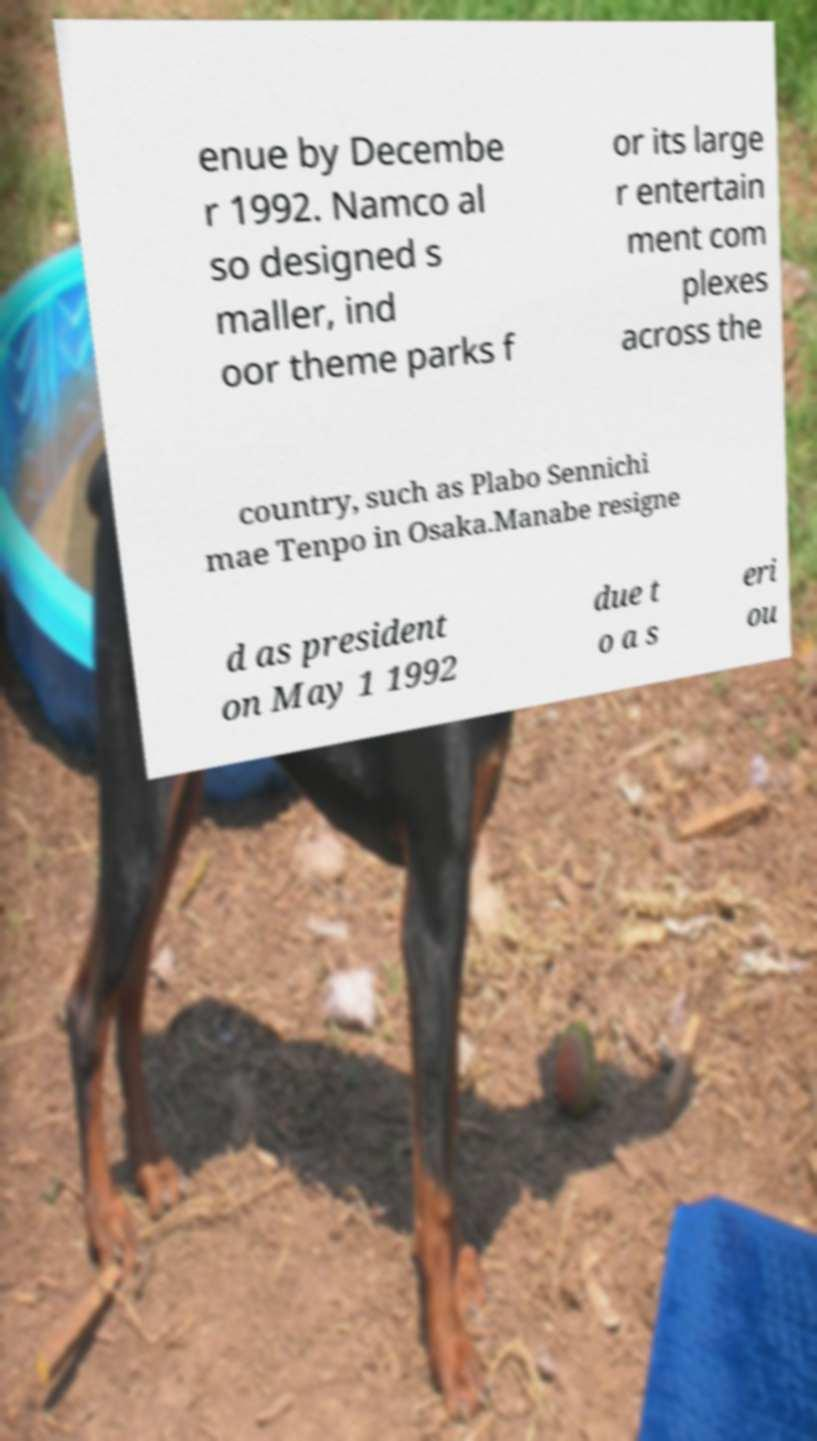I need the written content from this picture converted into text. Can you do that? enue by Decembe r 1992. Namco al so designed s maller, ind oor theme parks f or its large r entertain ment com plexes across the country, such as Plabo Sennichi mae Tenpo in Osaka.Manabe resigne d as president on May 1 1992 due t o a s eri ou 